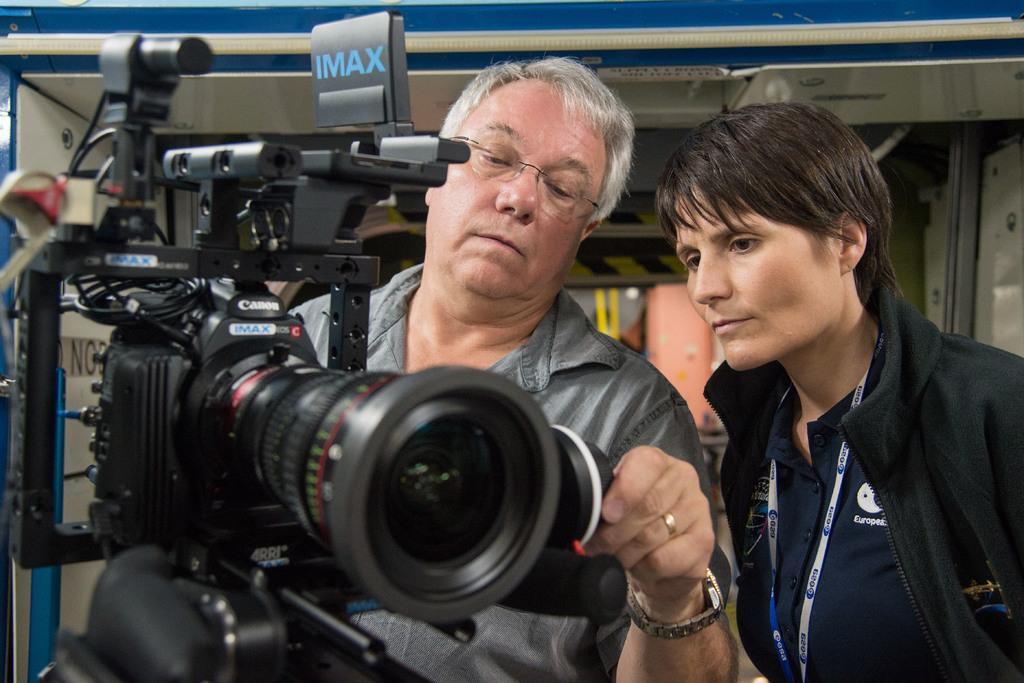Describe this image in one or two sentences. This picture shows a man holding a camera and a woman watching it 